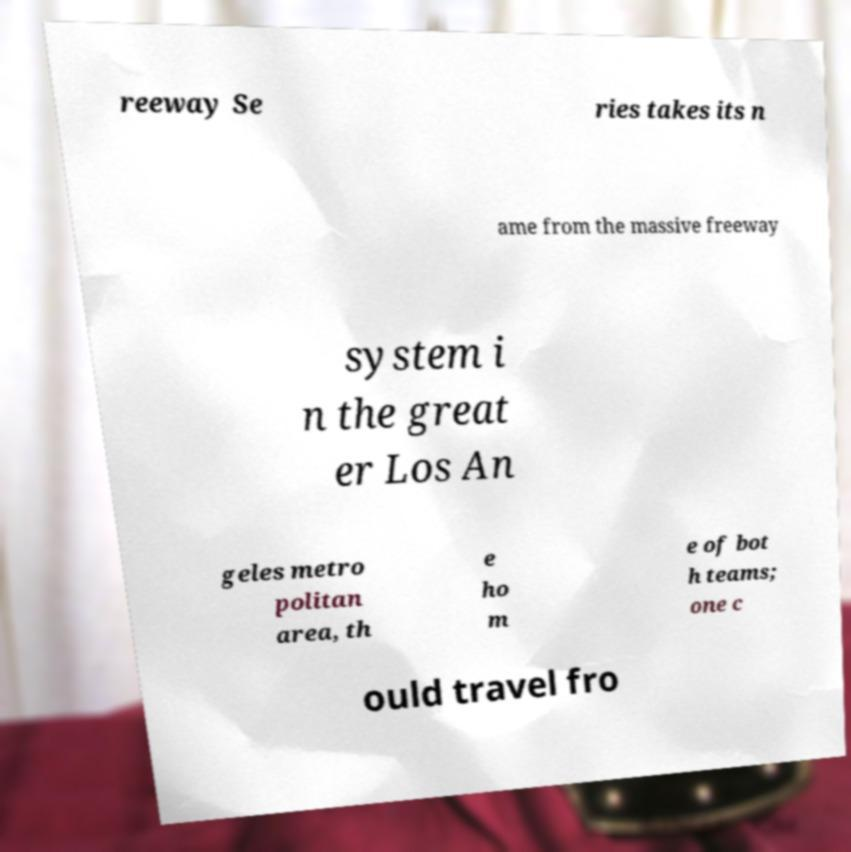Could you assist in decoding the text presented in this image and type it out clearly? reeway Se ries takes its n ame from the massive freeway system i n the great er Los An geles metro politan area, th e ho m e of bot h teams; one c ould travel fro 